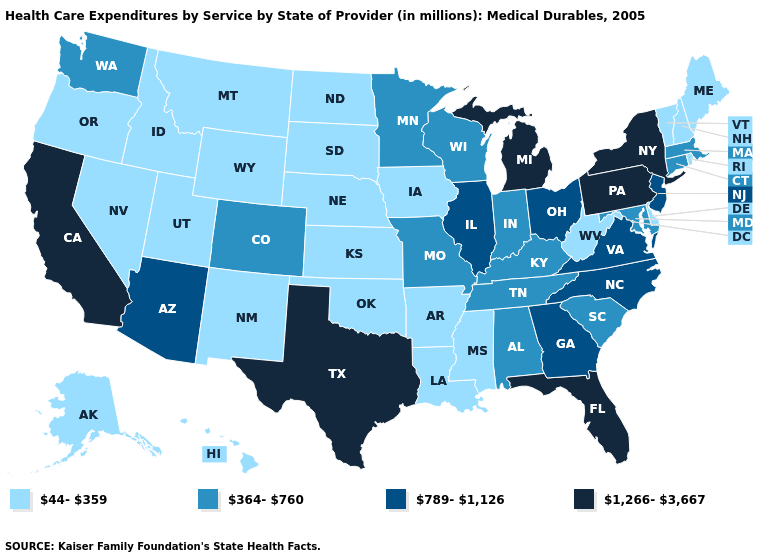Which states have the highest value in the USA?
Concise answer only. California, Florida, Michigan, New York, Pennsylvania, Texas. What is the value of Kentucky?
Be succinct. 364-760. What is the value of Oregon?
Answer briefly. 44-359. Which states have the lowest value in the Northeast?
Write a very short answer. Maine, New Hampshire, Rhode Island, Vermont. Name the states that have a value in the range 1,266-3,667?
Answer briefly. California, Florida, Michigan, New York, Pennsylvania, Texas. Name the states that have a value in the range 789-1,126?
Write a very short answer. Arizona, Georgia, Illinois, New Jersey, North Carolina, Ohio, Virginia. Does Maryland have the highest value in the South?
Be succinct. No. Which states have the lowest value in the USA?
Concise answer only. Alaska, Arkansas, Delaware, Hawaii, Idaho, Iowa, Kansas, Louisiana, Maine, Mississippi, Montana, Nebraska, Nevada, New Hampshire, New Mexico, North Dakota, Oklahoma, Oregon, Rhode Island, South Dakota, Utah, Vermont, West Virginia, Wyoming. Name the states that have a value in the range 789-1,126?
Quick response, please. Arizona, Georgia, Illinois, New Jersey, North Carolina, Ohio, Virginia. What is the value of New Mexico?
Short answer required. 44-359. How many symbols are there in the legend?
Be succinct. 4. Name the states that have a value in the range 1,266-3,667?
Write a very short answer. California, Florida, Michigan, New York, Pennsylvania, Texas. What is the value of New Mexico?
Short answer required. 44-359. What is the value of Arizona?
Answer briefly. 789-1,126. What is the value of Maryland?
Be succinct. 364-760. 